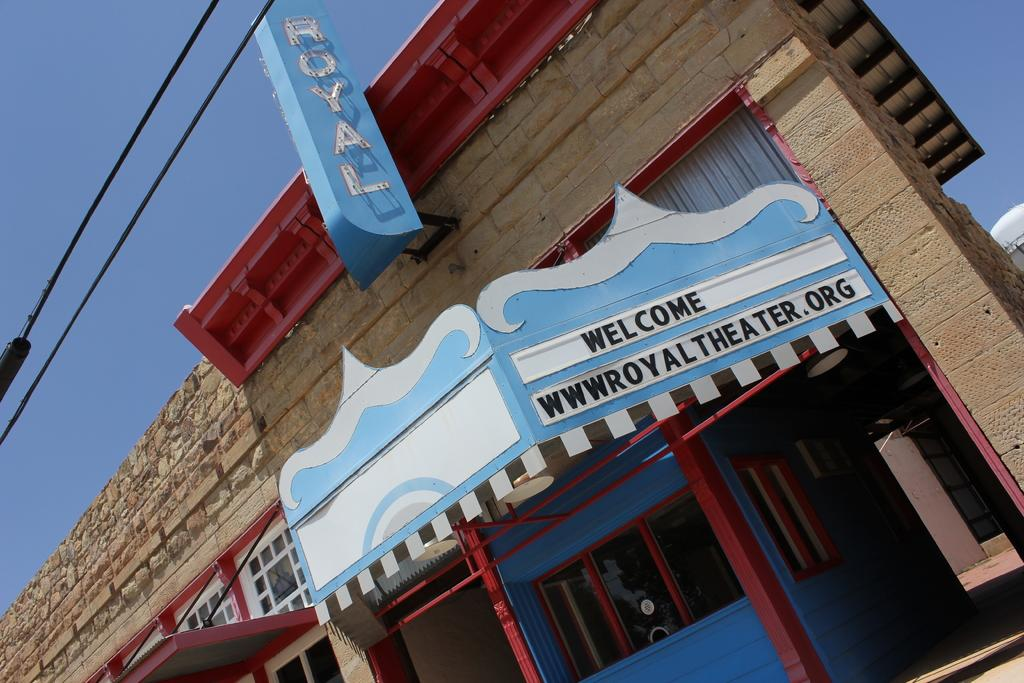<image>
Render a clear and concise summary of the photo. The entrance of the building which has the writing Welcome wwwroyaltheater.org 